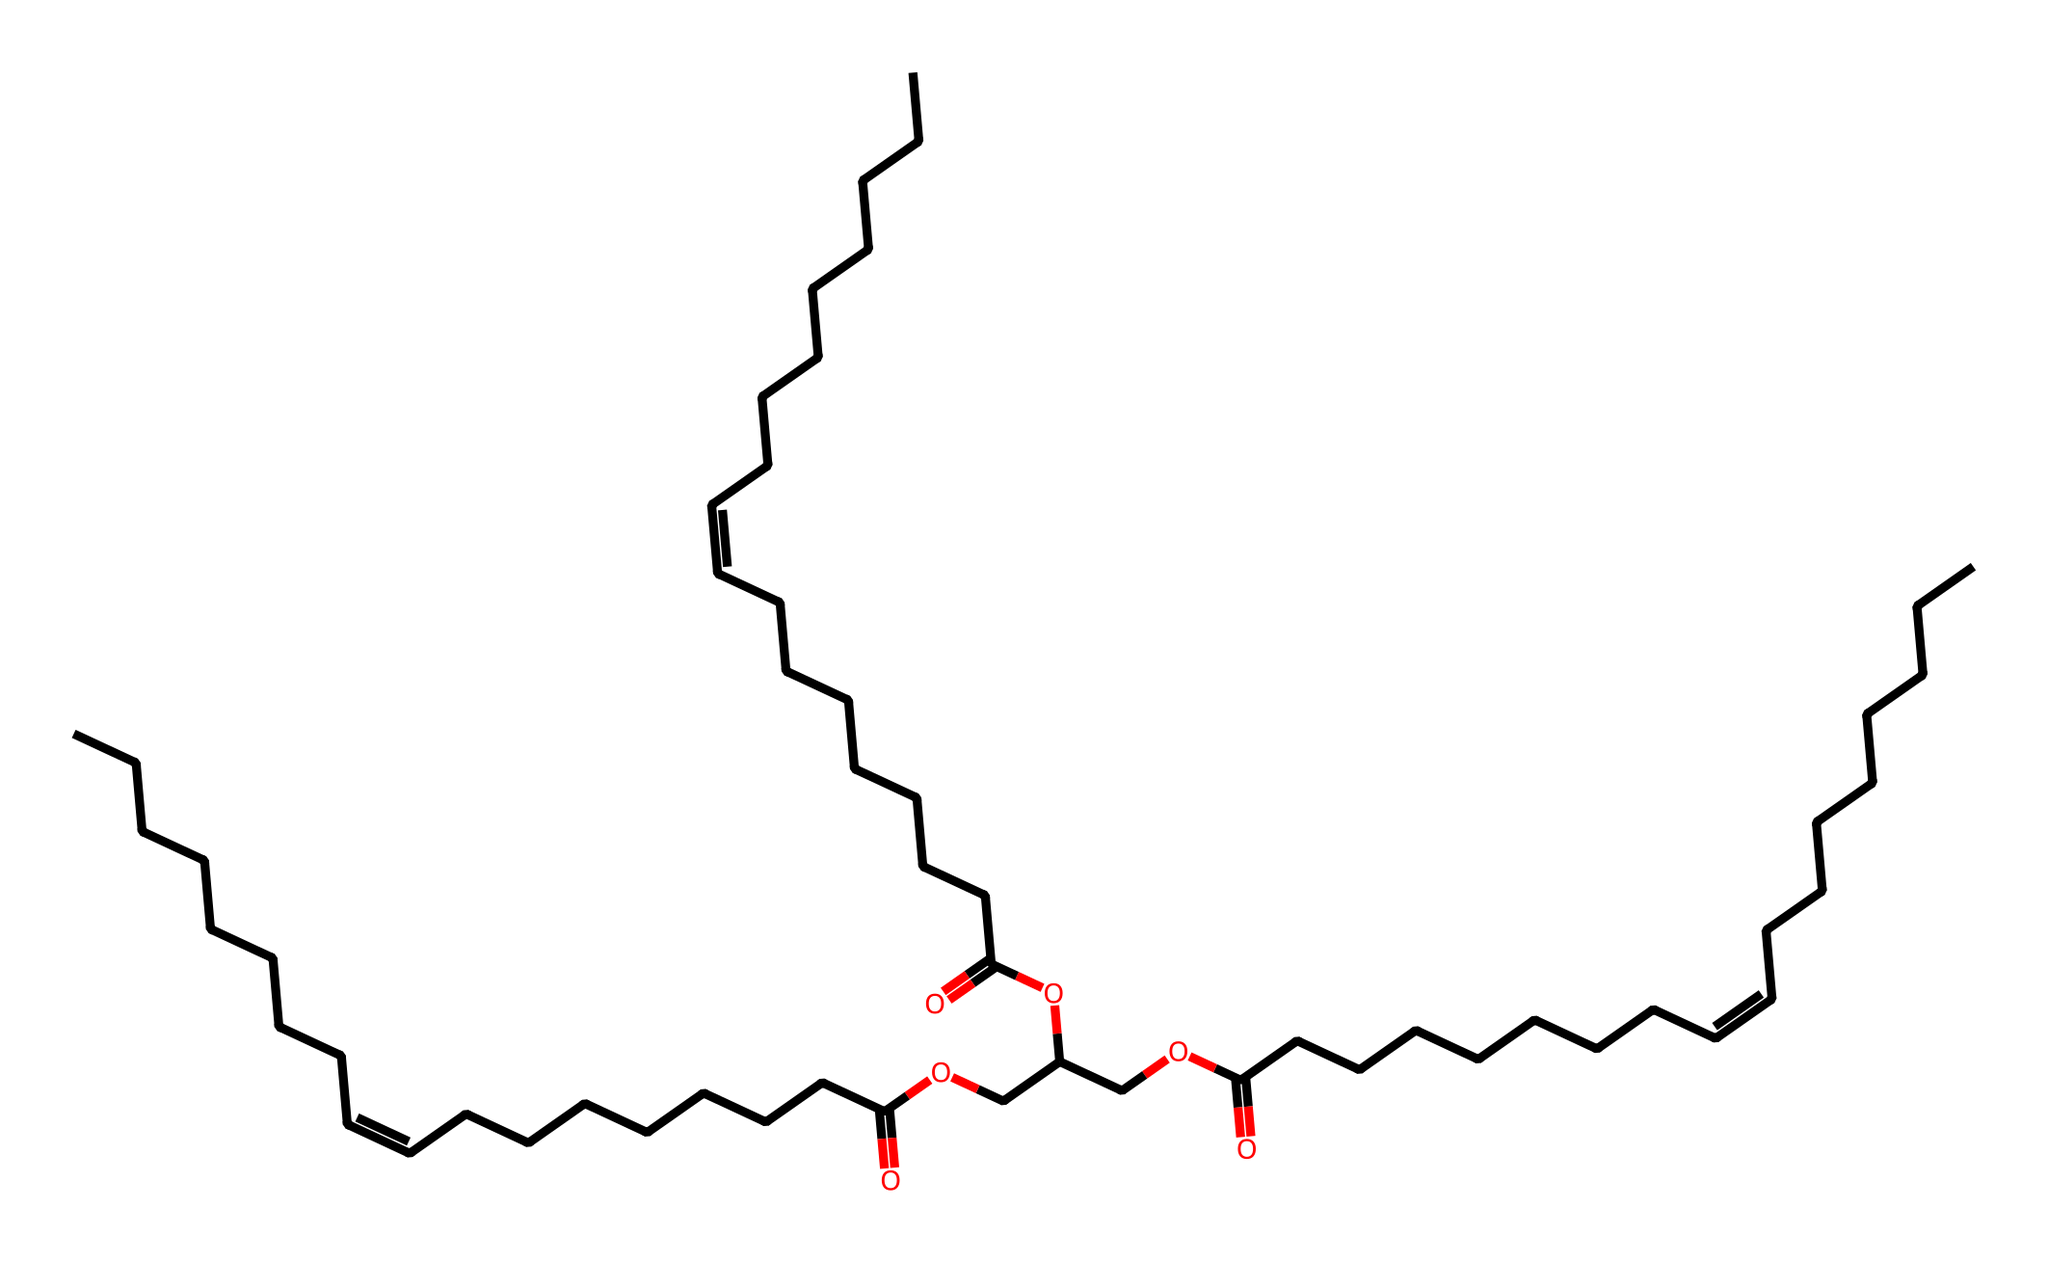What is the main functional group present in linseed oil? The structure contains a carboxylic acid functional group, which can be identified by the presence of the -COOH moiety.
Answer: carboxylic acid How many carbon atoms are in linseed oil? By counting the carbon atoms in the provided SMILES representation, there are 34 carbon atoms.
Answer: 34 Does linseed oil have any unsaturated bonds? The SMILES representation indicates a double bond (C=C) presence, confirming the existence of unsaturated bonds.
Answer: yes What type of chemical is linseed oil primarily used as? Linseed oil is commonly used as a solvent and wood finish due to its drying properties.
Answer: solvent Which part of the chemical structure is responsible for its drying properties? The presence of the unsaturated bonds (C=C) within the fatty acid chains facilitates the drying process upon oxidation.
Answer: unsaturated bonds How many double bonds are present in the structure of linseed oil? The analysis of the SMILES structure shows multiple instances of double bonds, indicating there are three double bonds.
Answer: 3 What does the ester functional group indicate about linseed oil? The ester functional group suggests that linseed oil can form cross-links during drying, contributing to its hardness as a wood finish.
Answer: cross-links 